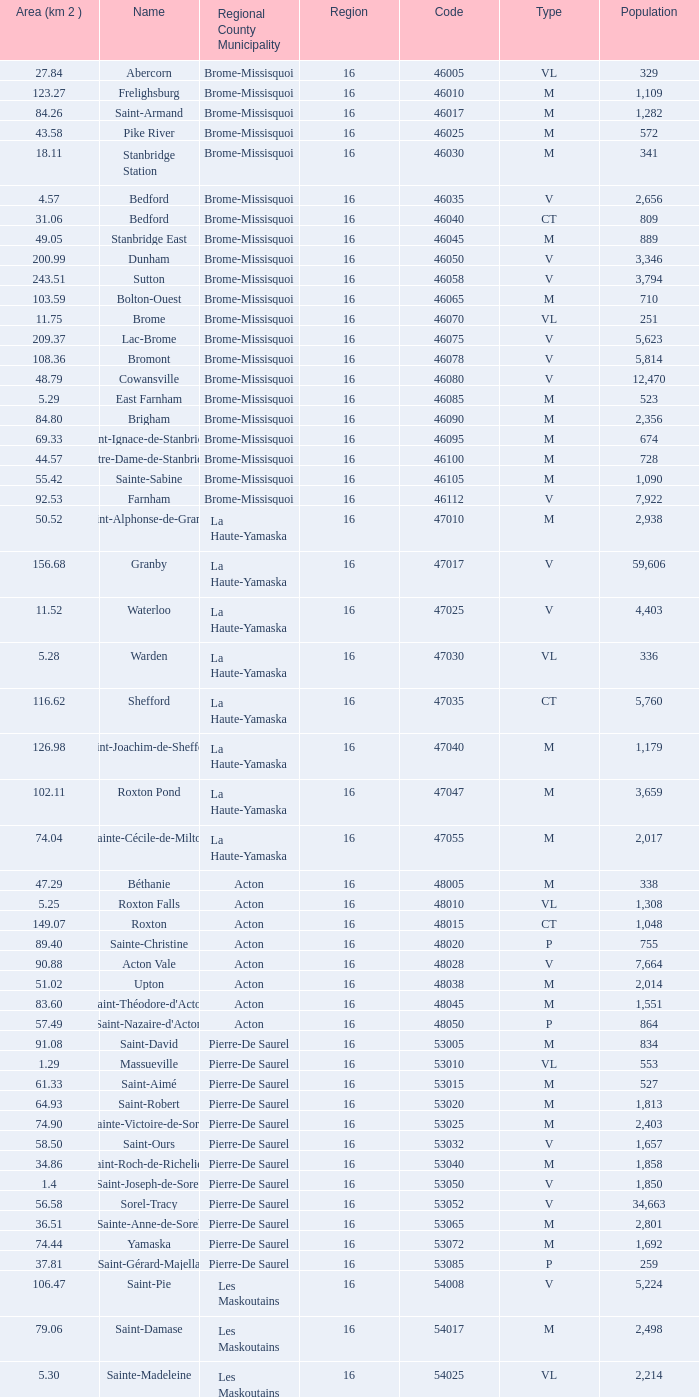Cowansville has less than 16 regions and is a Brome-Missisquoi Municipality, what is their population? None. 